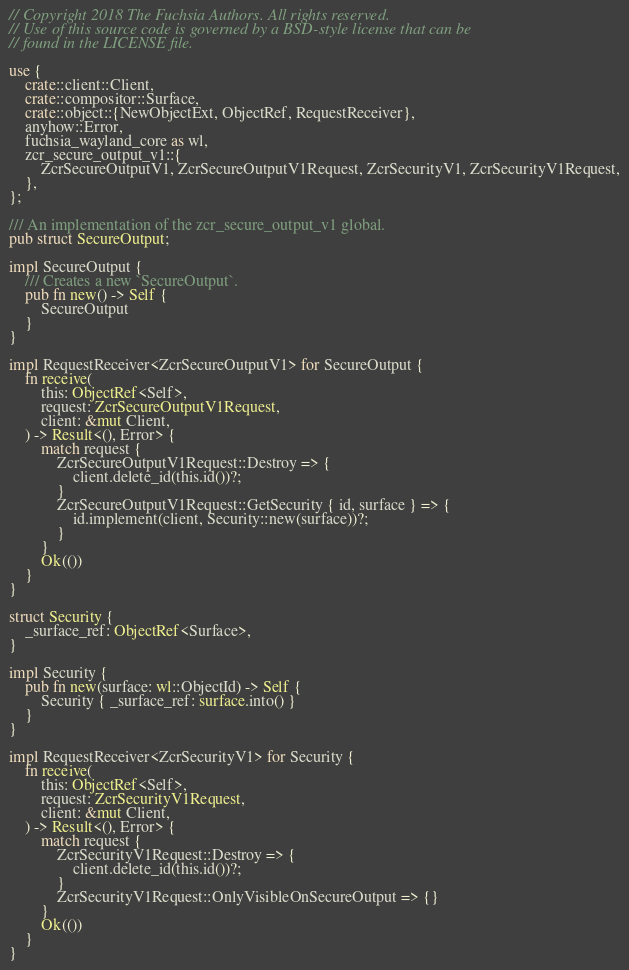Convert code to text. <code><loc_0><loc_0><loc_500><loc_500><_Rust_>// Copyright 2018 The Fuchsia Authors. All rights reserved.
// Use of this source code is governed by a BSD-style license that can be
// found in the LICENSE file.

use {
    crate::client::Client,
    crate::compositor::Surface,
    crate::object::{NewObjectExt, ObjectRef, RequestReceiver},
    anyhow::Error,
    fuchsia_wayland_core as wl,
    zcr_secure_output_v1::{
        ZcrSecureOutputV1, ZcrSecureOutputV1Request, ZcrSecurityV1, ZcrSecurityV1Request,
    },
};

/// An implementation of the zcr_secure_output_v1 global.
pub struct SecureOutput;

impl SecureOutput {
    /// Creates a new `SecureOutput`.
    pub fn new() -> Self {
        SecureOutput
    }
}

impl RequestReceiver<ZcrSecureOutputV1> for SecureOutput {
    fn receive(
        this: ObjectRef<Self>,
        request: ZcrSecureOutputV1Request,
        client: &mut Client,
    ) -> Result<(), Error> {
        match request {
            ZcrSecureOutputV1Request::Destroy => {
                client.delete_id(this.id())?;
            }
            ZcrSecureOutputV1Request::GetSecurity { id, surface } => {
                id.implement(client, Security::new(surface))?;
            }
        }
        Ok(())
    }
}

struct Security {
    _surface_ref: ObjectRef<Surface>,
}

impl Security {
    pub fn new(surface: wl::ObjectId) -> Self {
        Security { _surface_ref: surface.into() }
    }
}

impl RequestReceiver<ZcrSecurityV1> for Security {
    fn receive(
        this: ObjectRef<Self>,
        request: ZcrSecurityV1Request,
        client: &mut Client,
    ) -> Result<(), Error> {
        match request {
            ZcrSecurityV1Request::Destroy => {
                client.delete_id(this.id())?;
            }
            ZcrSecurityV1Request::OnlyVisibleOnSecureOutput => {}
        }
        Ok(())
    }
}
</code> 